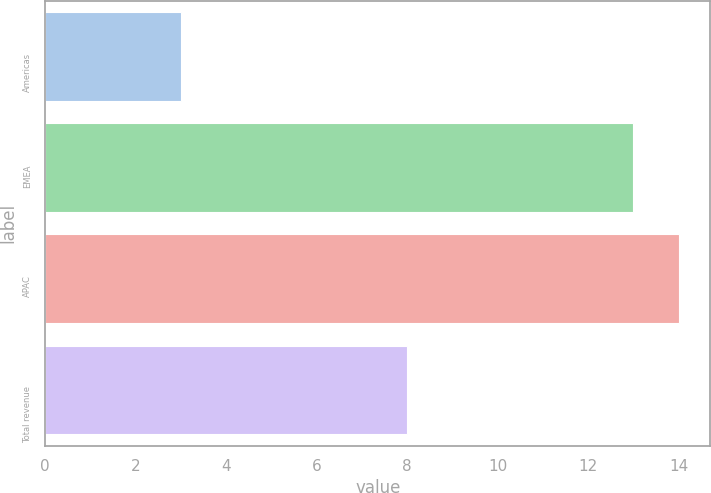Convert chart to OTSL. <chart><loc_0><loc_0><loc_500><loc_500><bar_chart><fcel>Americas<fcel>EMEA<fcel>APAC<fcel>Total revenue<nl><fcel>3<fcel>13<fcel>14<fcel>8<nl></chart> 